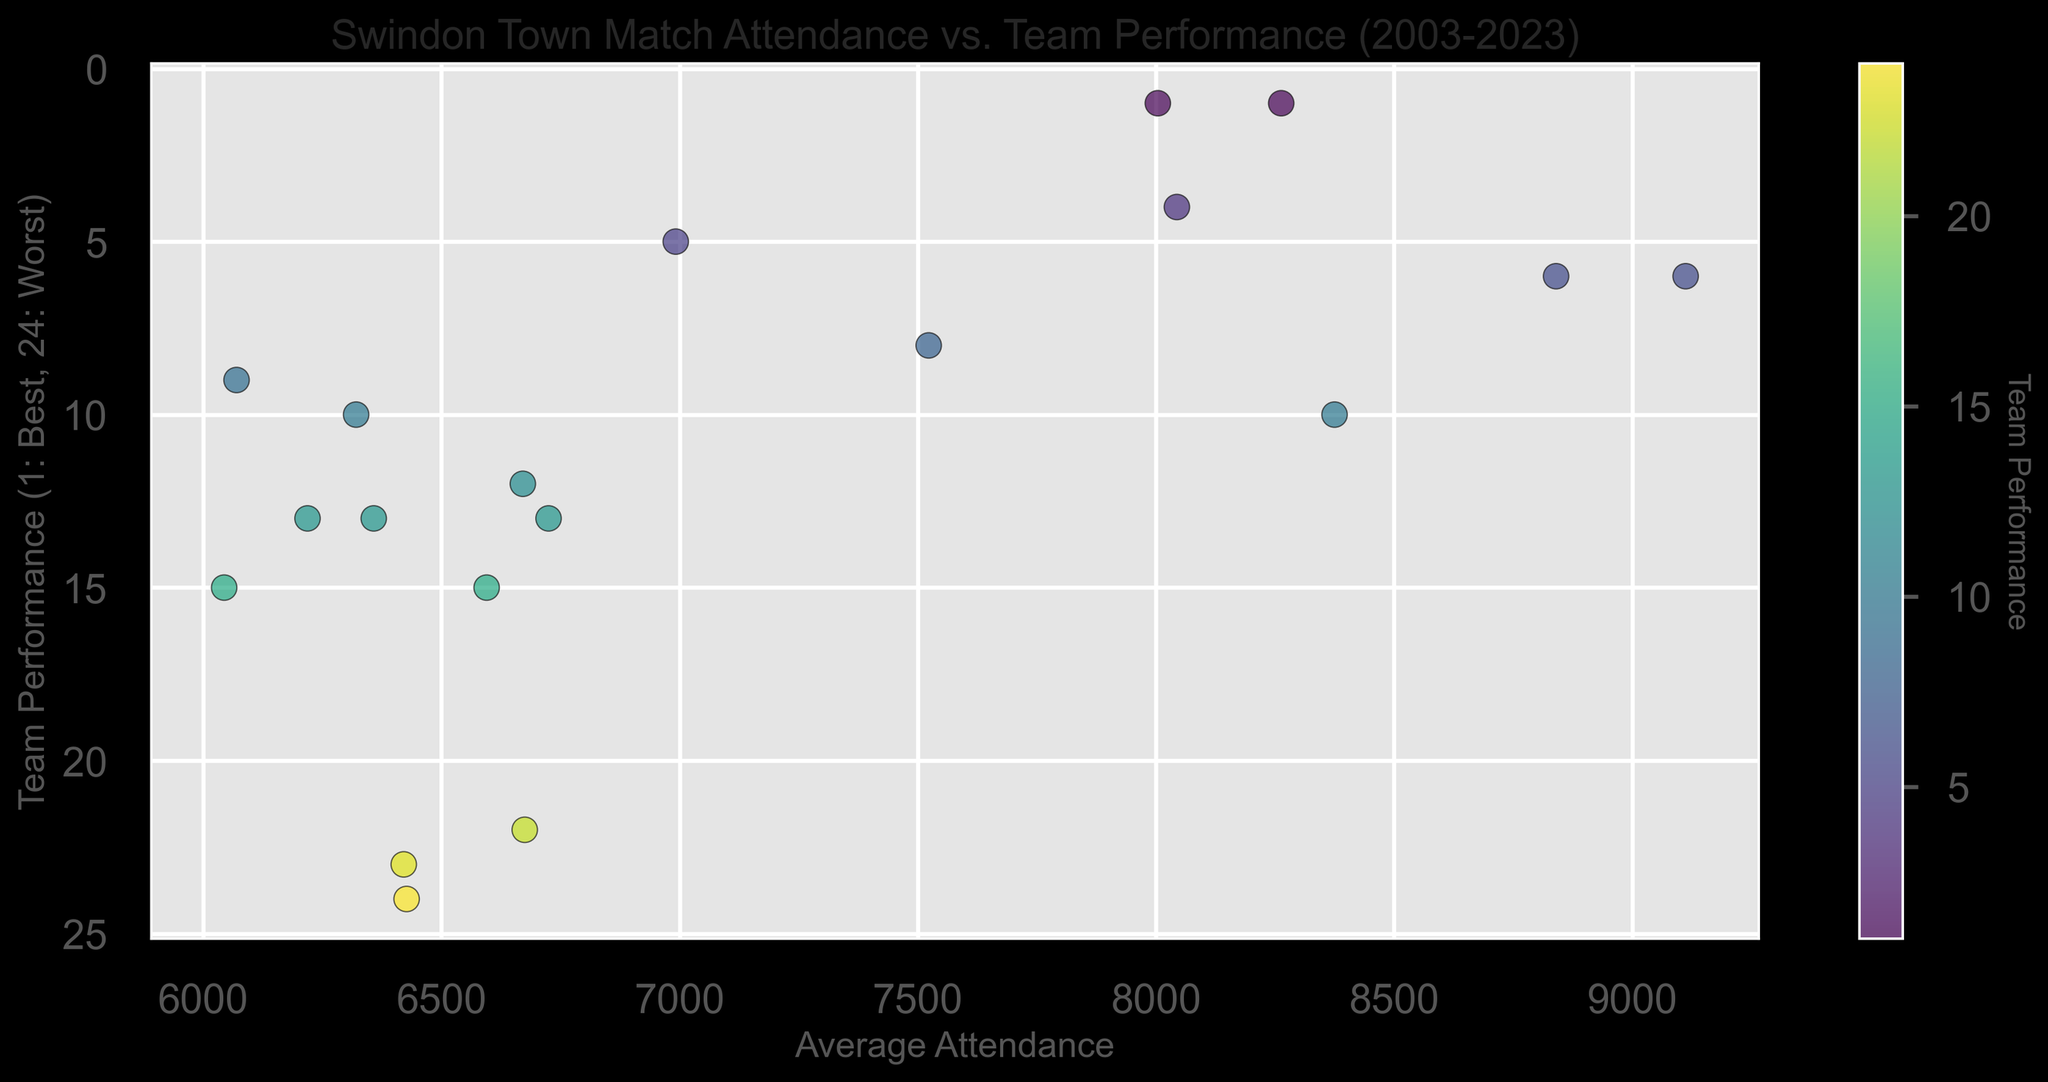What's the general trend between average attendance and team performance? From the scatter plot, there's a general trend where better team performance (lower numeric rank) tends to correspond with higher average attendance, evidenced by the upward clustering of points towards the left side of the x-axis.
Answer: Better performance generally correlates with higher attendance Which season had the highest average attendance and what was the team performance that year? By observing the scatter plot, the highest average attendance occurs around 9112 for the 2021-2022 season. The corresponding team performance is 6.
Answer: 2021-2022 season, performance rank 6 What can be inferred from points that are darker in color? The plot uses a color gradient where darker colors represent better team performance (lower numeric rank). Thus, points with darker colors suggest seasons with higher team performance.
Answer: Better team performance How did the average attendance compare between the 2009-2010 and 2011-2012 seasons? In the plot, the point for the 2009-2010 season (approx. 6992) is lower compared to the point for the 2011-2012 season (approx. 8004). Therefore, the average attendance was higher in the 2011-2012 season.
Answer: Higher in 2011-2012 Which performance rank corresponds to the lowest average attendance? From the scatter plot, the point with the lowest average attendance is around 6044, which corresponds to a team performance rank of 15.
Answer: Performance rank 15 What is the relationship between attendance and team performance for the best performing season? The best performing seasons are marked as having a rank of 1. These points are generally placed higher on the y-axis, showing high average attendance (approximately 8004 and 8263). This indicates that in the best-performing seasons, the average attendance was high.
Answer: High attendance for best performance How did the average attendance and performance vary in the seasons where the team ranked 1st? From the scatter plot, there are two points where the team performance is ranked 1 (one in 2011-2012 with around 8004 attendance and another in 2019-2020 with around 8263 attendance). So, both seasons show a relatively high average attendance.
Answer: High average attendance in both seasons For seasons with an average attendance above 8000, what range of performance ranks is observed? Observing the plot, there are several points with average attendance above 8000, and their performance ranks range between 1 and 10. This indicates better team performances.
Answer: Range from 1 to 10 Calculate the average performance rank for seasons with attendance above 8000. Points with attendance above 8000 include performance ranks of 1, 6, 4, 1, and 6. Summing these up: (1+6+4+1+6) = 18, and there are 5 seasons, so the average is 18/5 = 3.6.
Answer: 3.6 Identify any outlier(s) regarding attendance vs. performance and explain why they seem unusual. An outlier might be a season that doesn’t follow the general trend where better performance corresponds with higher attendance. A key outlier is the season with an attendance around 9112 (2021-2022) and performance rank 6, which stands out with distinctly high attendance compared to its performance rank.
Answer: Attendance: 9112, Performance: 6 